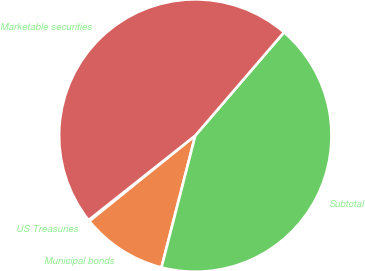<chart> <loc_0><loc_0><loc_500><loc_500><pie_chart><fcel>US Treasuries<fcel>Municipal bonds<fcel>Subtotal<fcel>Marketable securities<nl><fcel>0.15%<fcel>10.19%<fcel>42.7%<fcel>46.96%<nl></chart> 